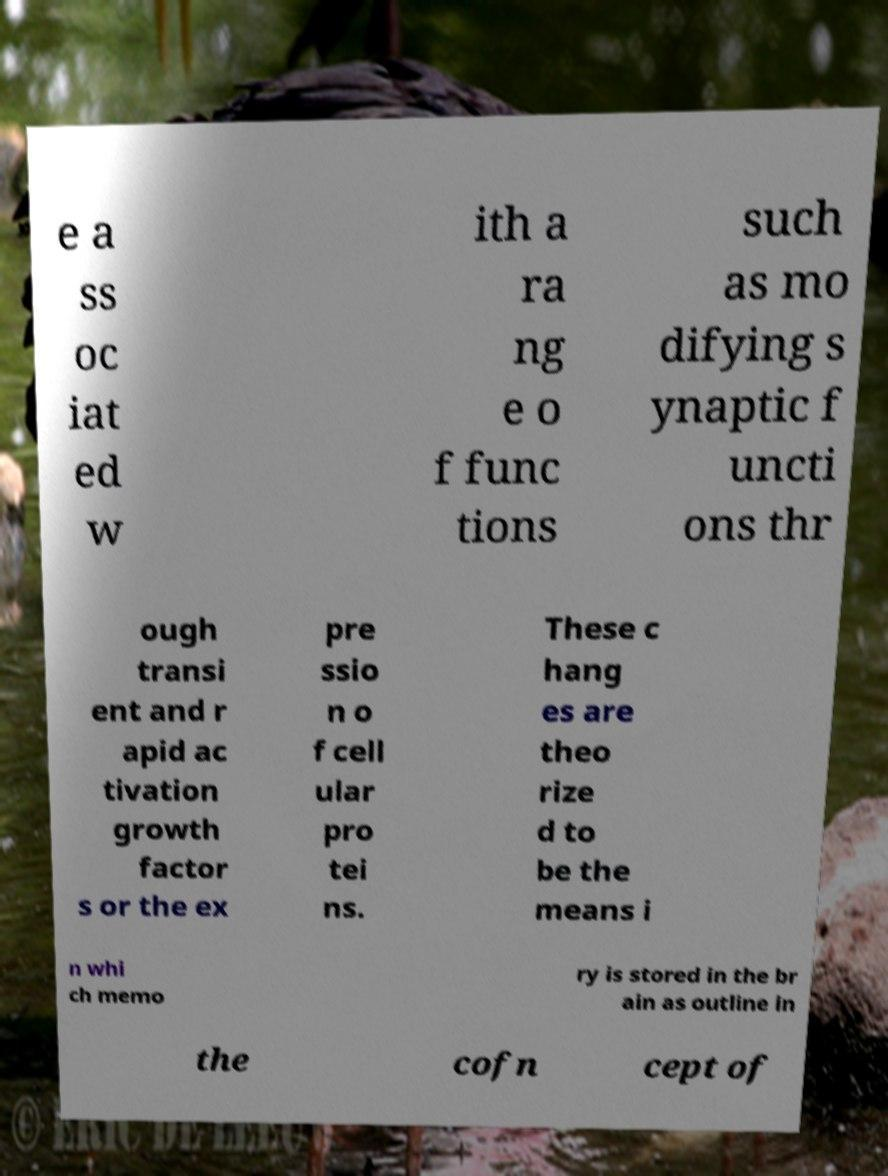Can you explain the scientific context mentioned in the text of this image? The text refers to the role of specific biological processes in the shaping of memory. It discusses how synaptic functions and the activation of growth factors, as well as protein expression, might contribute to the physiological basis for memory storage in the brain. 